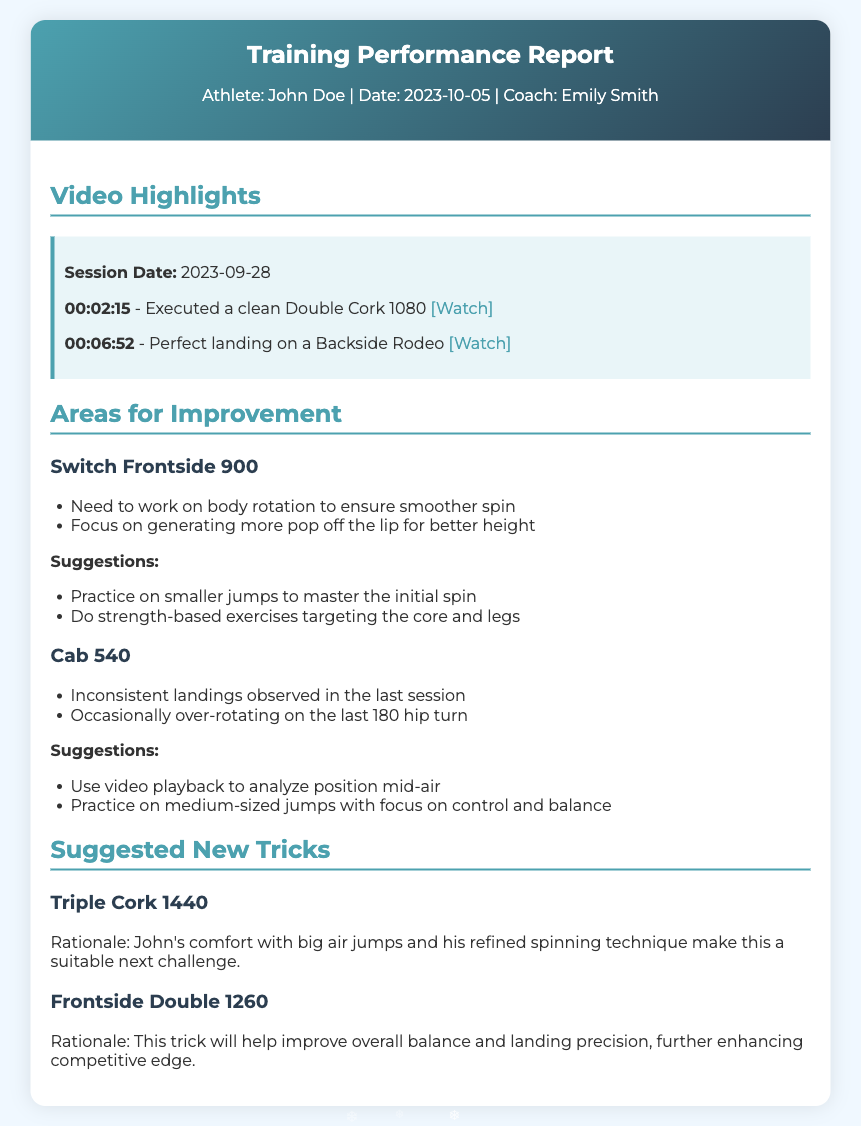what is the athlete's name? The athlete's name is mentioned in the header section of the report.
Answer: John Doe who is the coach? The coach's name is included in the header along with the athlete and date.
Answer: Emily Smith what date was the report created? The report date is specified in the header alongside the athlete and coach.
Answer: 2023-10-05 how many video highlights are listed? The number of video highlights can be counted from the content section of the report.
Answer: 2 which trick had inconsistent landings observed? This trick is mentioned in the "Areas for Improvement" section.
Answer: Cab 540 what is the suggested new trick for balance and landing precision? This trick is highlighted in the "Suggested New Tricks" section with reasoning provided.
Answer: Frontside Double 1260 what is suggested for practicing the Switch Frontside 900? Suggestions provided under "Areas for Improvement" list specific practices.
Answer: Practice on smaller jumps what is the rationale for suggesting the Triple Cork 1440? The reasoning behind the new trick suggestion is based on the athlete's abilities.
Answer: Comfort with big air jumps how many areas for improvement are there? The count of areas for improvement can be inferred from sections in the document.
Answer: 2 